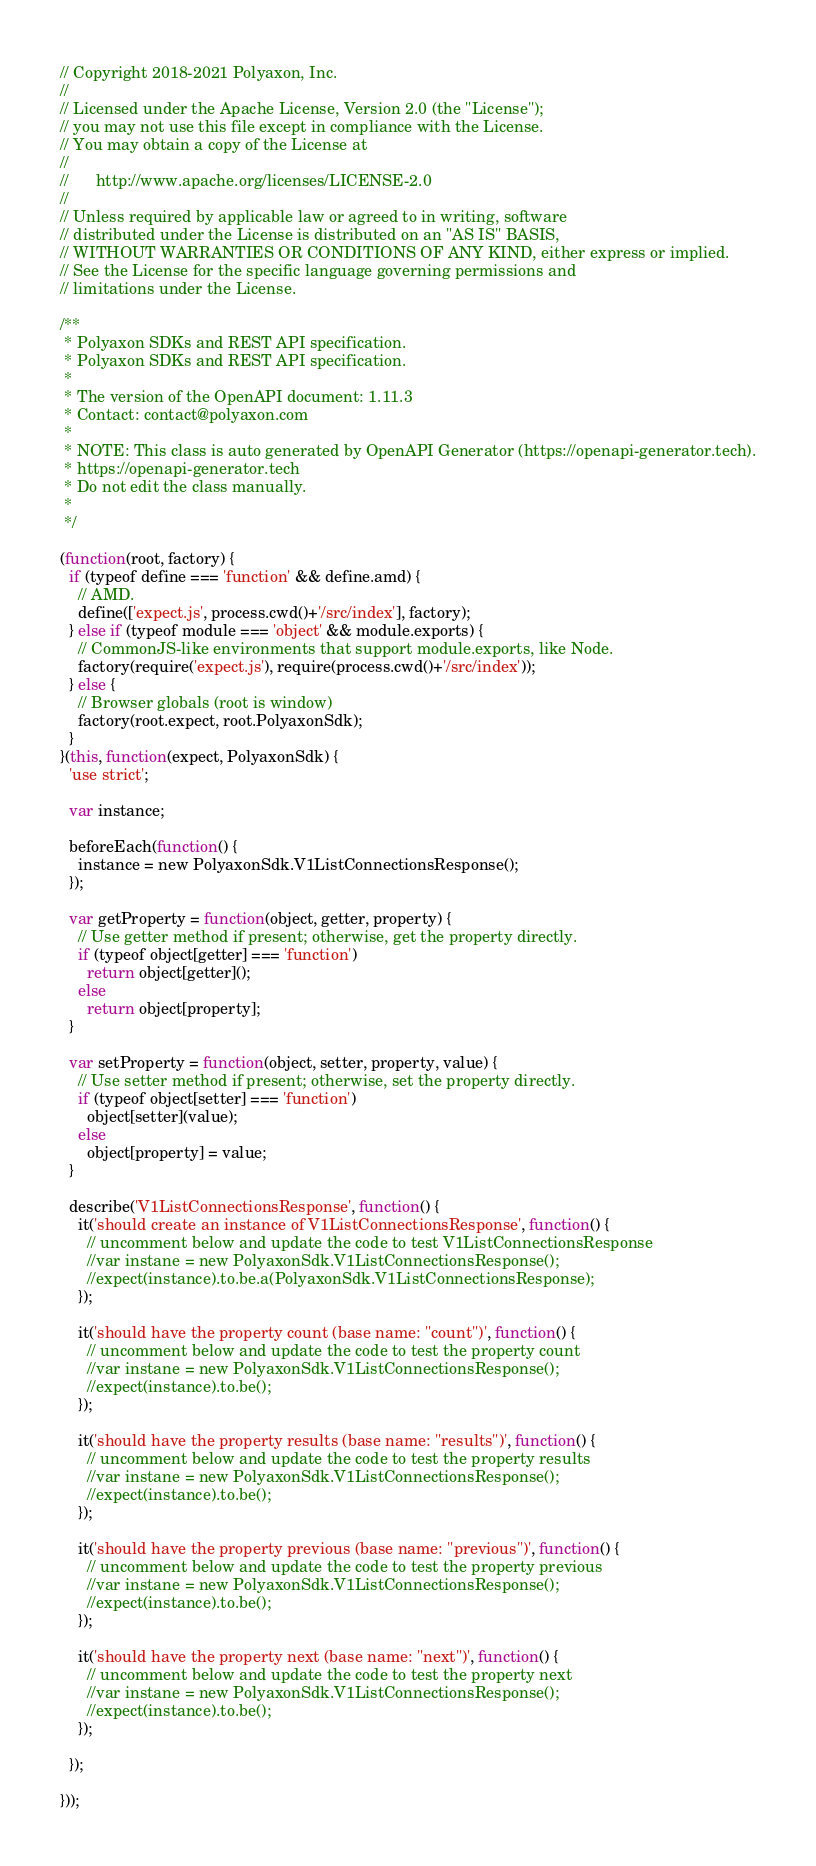<code> <loc_0><loc_0><loc_500><loc_500><_JavaScript_>// Copyright 2018-2021 Polyaxon, Inc.
//
// Licensed under the Apache License, Version 2.0 (the "License");
// you may not use this file except in compliance with the License.
// You may obtain a copy of the License at
//
//      http://www.apache.org/licenses/LICENSE-2.0
//
// Unless required by applicable law or agreed to in writing, software
// distributed under the License is distributed on an "AS IS" BASIS,
// WITHOUT WARRANTIES OR CONDITIONS OF ANY KIND, either express or implied.
// See the License for the specific language governing permissions and
// limitations under the License.

/**
 * Polyaxon SDKs and REST API specification.
 * Polyaxon SDKs and REST API specification.
 *
 * The version of the OpenAPI document: 1.11.3
 * Contact: contact@polyaxon.com
 *
 * NOTE: This class is auto generated by OpenAPI Generator (https://openapi-generator.tech).
 * https://openapi-generator.tech
 * Do not edit the class manually.
 *
 */

(function(root, factory) {
  if (typeof define === 'function' && define.amd) {
    // AMD.
    define(['expect.js', process.cwd()+'/src/index'], factory);
  } else if (typeof module === 'object' && module.exports) {
    // CommonJS-like environments that support module.exports, like Node.
    factory(require('expect.js'), require(process.cwd()+'/src/index'));
  } else {
    // Browser globals (root is window)
    factory(root.expect, root.PolyaxonSdk);
  }
}(this, function(expect, PolyaxonSdk) {
  'use strict';

  var instance;

  beforeEach(function() {
    instance = new PolyaxonSdk.V1ListConnectionsResponse();
  });

  var getProperty = function(object, getter, property) {
    // Use getter method if present; otherwise, get the property directly.
    if (typeof object[getter] === 'function')
      return object[getter]();
    else
      return object[property];
  }

  var setProperty = function(object, setter, property, value) {
    // Use setter method if present; otherwise, set the property directly.
    if (typeof object[setter] === 'function')
      object[setter](value);
    else
      object[property] = value;
  }

  describe('V1ListConnectionsResponse', function() {
    it('should create an instance of V1ListConnectionsResponse', function() {
      // uncomment below and update the code to test V1ListConnectionsResponse
      //var instane = new PolyaxonSdk.V1ListConnectionsResponse();
      //expect(instance).to.be.a(PolyaxonSdk.V1ListConnectionsResponse);
    });

    it('should have the property count (base name: "count")', function() {
      // uncomment below and update the code to test the property count
      //var instane = new PolyaxonSdk.V1ListConnectionsResponse();
      //expect(instance).to.be();
    });

    it('should have the property results (base name: "results")', function() {
      // uncomment below and update the code to test the property results
      //var instane = new PolyaxonSdk.V1ListConnectionsResponse();
      //expect(instance).to.be();
    });

    it('should have the property previous (base name: "previous")', function() {
      // uncomment below and update the code to test the property previous
      //var instane = new PolyaxonSdk.V1ListConnectionsResponse();
      //expect(instance).to.be();
    });

    it('should have the property next (base name: "next")', function() {
      // uncomment below and update the code to test the property next
      //var instane = new PolyaxonSdk.V1ListConnectionsResponse();
      //expect(instance).to.be();
    });

  });

}));
</code> 